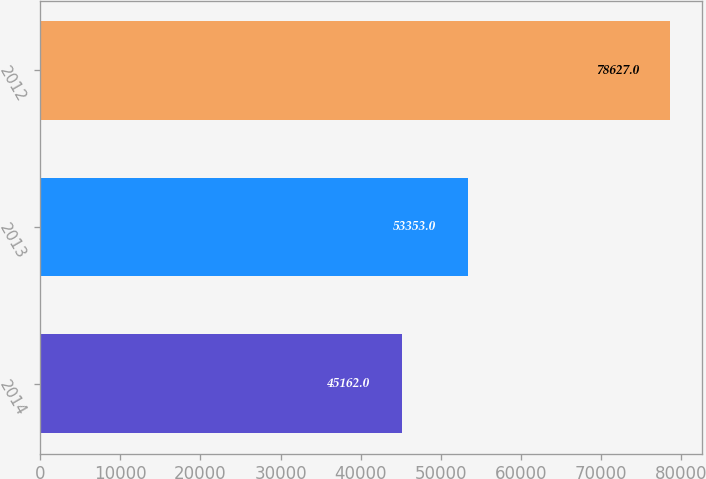Convert chart to OTSL. <chart><loc_0><loc_0><loc_500><loc_500><bar_chart><fcel>2014<fcel>2013<fcel>2012<nl><fcel>45162<fcel>53353<fcel>78627<nl></chart> 